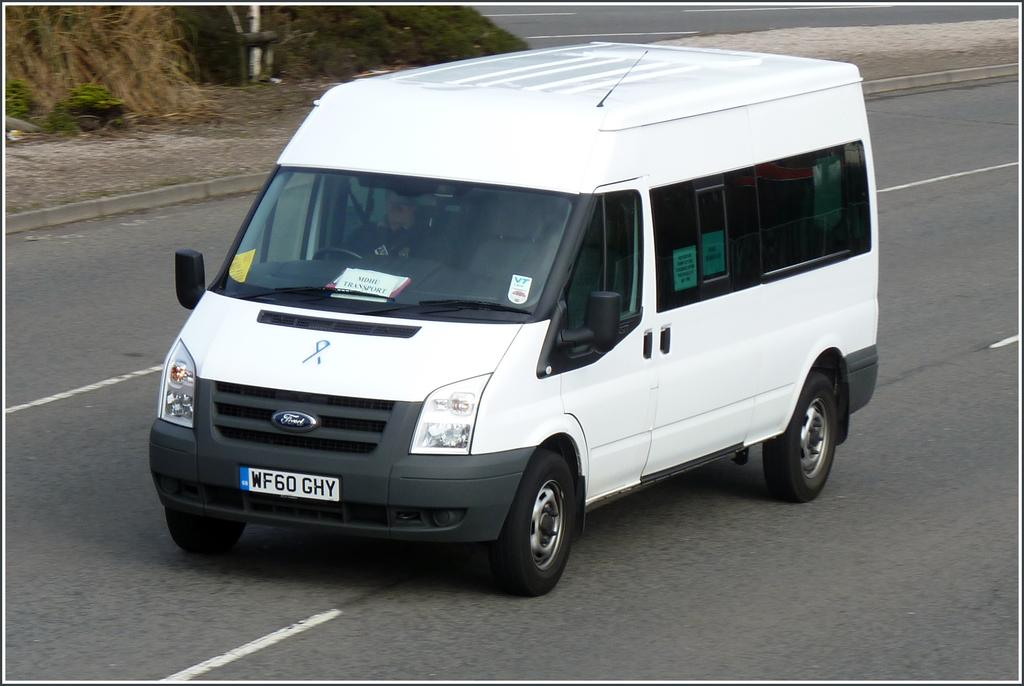What is the person in the image doing? There is a person sitting inside a vehicle in the image. Where is the vehicle located? The vehicle is parked on the road in the image. What can be seen in the background of the image? There is a pole and plants in the background of the image. What type of scarf is the person wearing in the image? There is no scarf visible in the image. What health benefits does the person in the image receive from sitting inside the vehicle? The image does not provide information about any health benefits the person may receive from sitting inside the vehicle. 